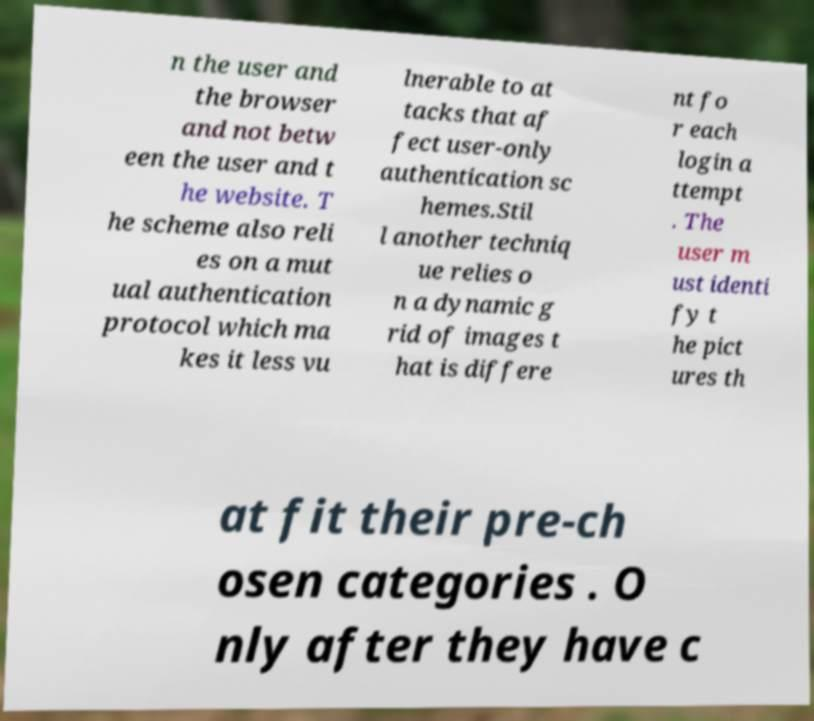What messages or text are displayed in this image? I need them in a readable, typed format. n the user and the browser and not betw een the user and t he website. T he scheme also reli es on a mut ual authentication protocol which ma kes it less vu lnerable to at tacks that af fect user-only authentication sc hemes.Stil l another techniq ue relies o n a dynamic g rid of images t hat is differe nt fo r each login a ttempt . The user m ust identi fy t he pict ures th at fit their pre-ch osen categories . O nly after they have c 